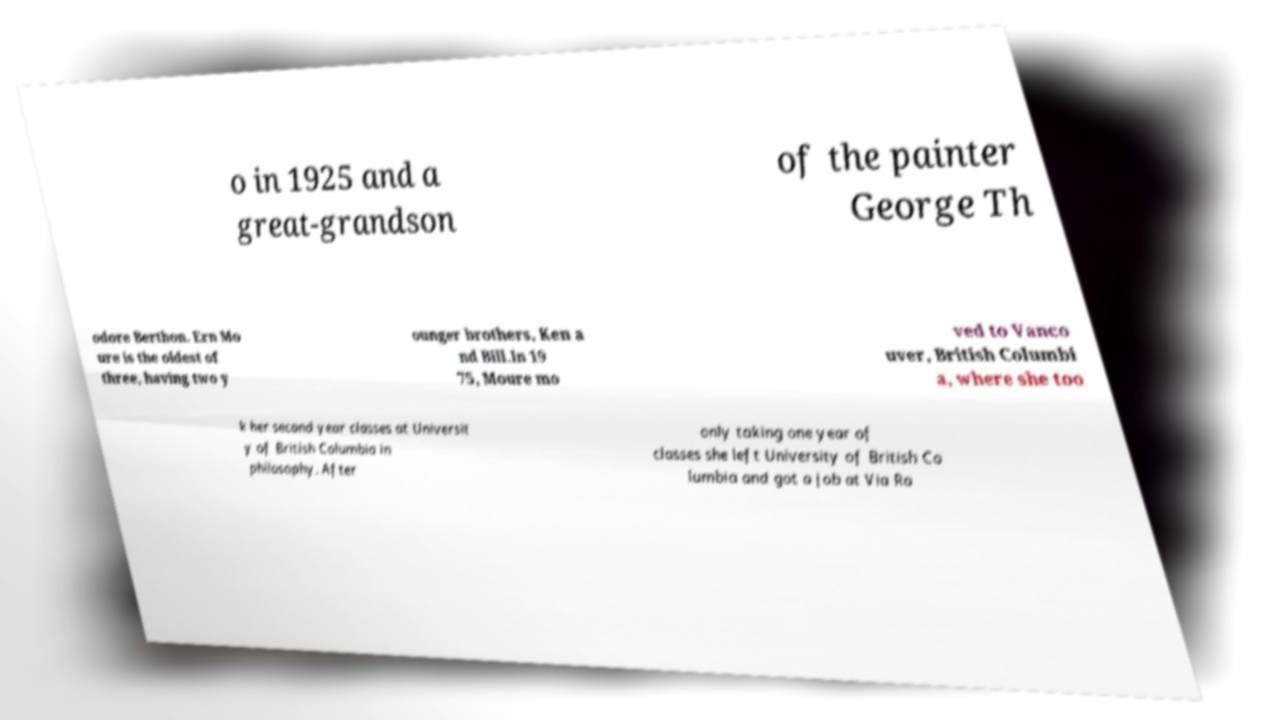Can you read and provide the text displayed in the image?This photo seems to have some interesting text. Can you extract and type it out for me? o in 1925 and a great-grandson of the painter George Th odore Berthon. Ern Mo ure is the oldest of three, having two y ounger brothers, Ken a nd Bill.In 19 75, Moure mo ved to Vanco uver, British Columbi a, where she too k her second year classes at Universit y of British Columbia in philosophy. After only taking one year of classes she left University of British Co lumbia and got a job at Via Ra 